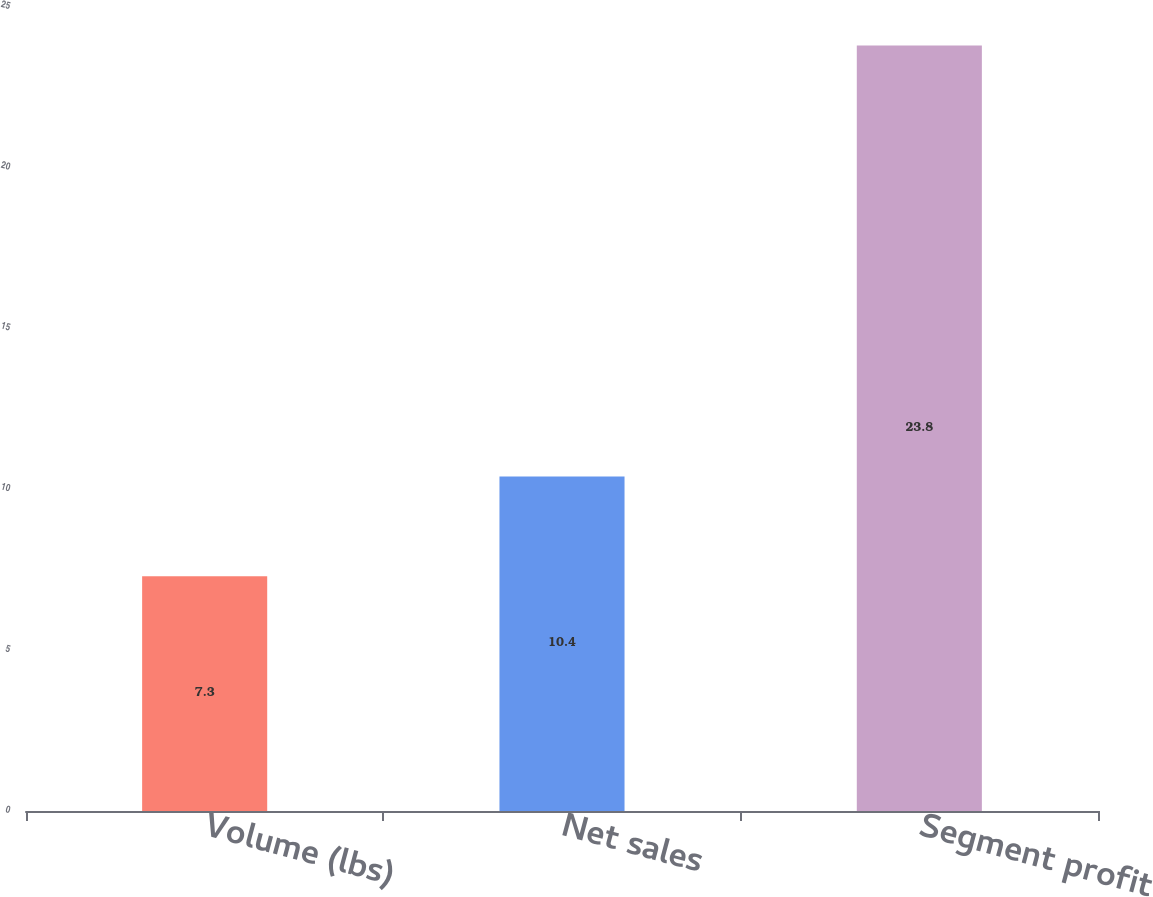Convert chart to OTSL. <chart><loc_0><loc_0><loc_500><loc_500><bar_chart><fcel>Volume (lbs)<fcel>Net sales<fcel>Segment profit<nl><fcel>7.3<fcel>10.4<fcel>23.8<nl></chart> 